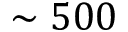<formula> <loc_0><loc_0><loc_500><loc_500>\sim 5 0 0</formula> 